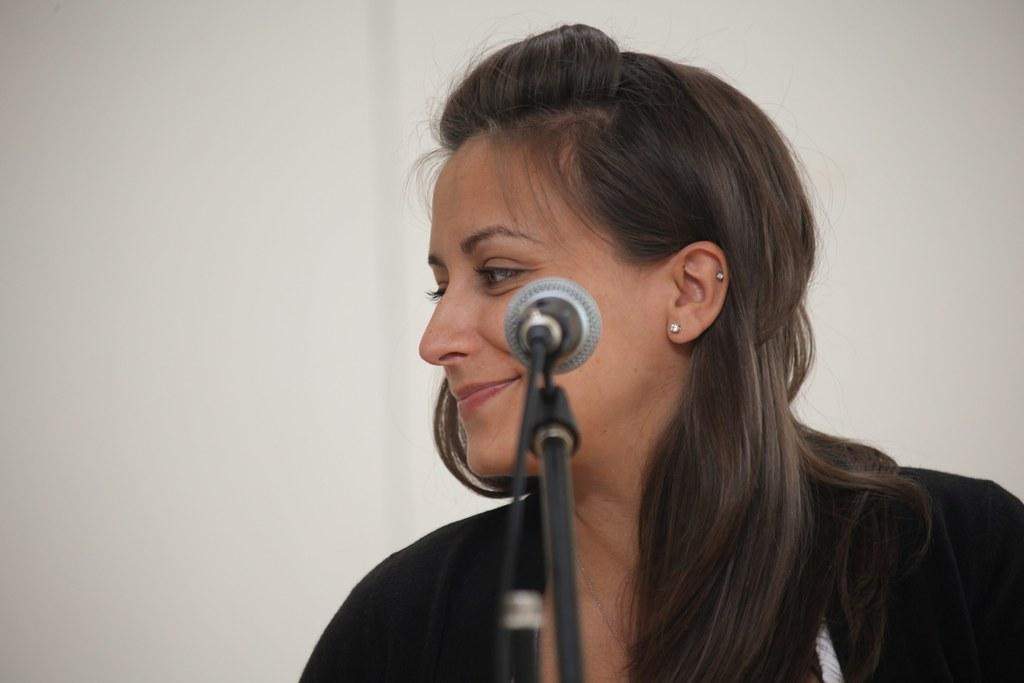Who is the main subject in the image? There is a lady in the image. What type of jewelry is the lady wearing? The lady is wearing ear studs. What object is present in the image that is typically used for amplifying sound? There is a microphone in the image. How is the microphone positioned in the image? The microphone is on a stand. What can be seen in the background of the image? There is a wall in the background of the image. What type of slope can be seen in the image? There is no slope present in the image. What is the reason for the lady holding the microphone in the image? The image does not provide any information about the reason for the lady holding the microphone. 